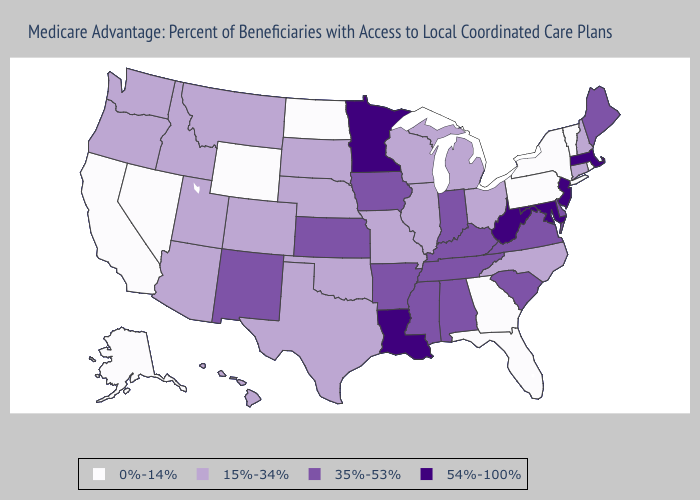What is the value of Washington?
Write a very short answer. 15%-34%. Does Kansas have the lowest value in the USA?
Write a very short answer. No. Which states have the lowest value in the USA?
Quick response, please. Alaska, California, Florida, Georgia, North Dakota, Nevada, New York, Pennsylvania, Rhode Island, Vermont, Wyoming. Name the states that have a value in the range 35%-53%?
Quick response, please. Alabama, Arkansas, Delaware, Iowa, Indiana, Kansas, Kentucky, Maine, Mississippi, New Mexico, South Carolina, Tennessee, Virginia. Does Louisiana have the highest value in the USA?
Concise answer only. Yes. What is the value of Iowa?
Give a very brief answer. 35%-53%. What is the value of Missouri?
Concise answer only. 15%-34%. Name the states that have a value in the range 0%-14%?
Quick response, please. Alaska, California, Florida, Georgia, North Dakota, Nevada, New York, Pennsylvania, Rhode Island, Vermont, Wyoming. Does New Jersey have the highest value in the USA?
Write a very short answer. Yes. What is the lowest value in states that border Rhode Island?
Keep it brief. 15%-34%. What is the value of Kentucky?
Give a very brief answer. 35%-53%. Does the map have missing data?
Keep it brief. No. Which states have the lowest value in the USA?
Write a very short answer. Alaska, California, Florida, Georgia, North Dakota, Nevada, New York, Pennsylvania, Rhode Island, Vermont, Wyoming. Does the first symbol in the legend represent the smallest category?
Concise answer only. Yes. Is the legend a continuous bar?
Give a very brief answer. No. 